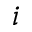<formula> <loc_0><loc_0><loc_500><loc_500>i</formula> 